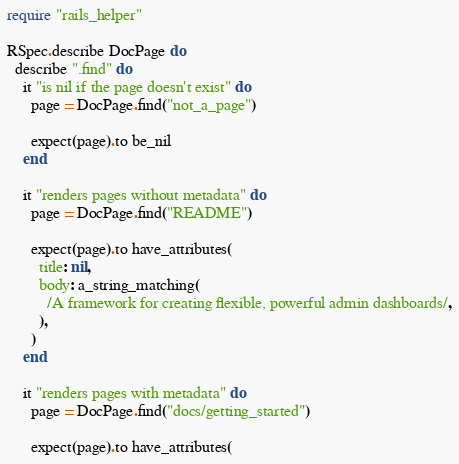Convert code to text. <code><loc_0><loc_0><loc_500><loc_500><_Ruby_>require "rails_helper"

RSpec.describe DocPage do
  describe ".find" do
    it "is nil if the page doesn't exist" do
      page = DocPage.find("not_a_page")

      expect(page).to be_nil
    end

    it "renders pages without metadata" do
      page = DocPage.find("README")

      expect(page).to have_attributes(
        title: nil,
        body: a_string_matching(
          /A framework for creating flexible, powerful admin dashboards/,
        ),
      )
    end

    it "renders pages with metadata" do
      page = DocPage.find("docs/getting_started")

      expect(page).to have_attributes(</code> 